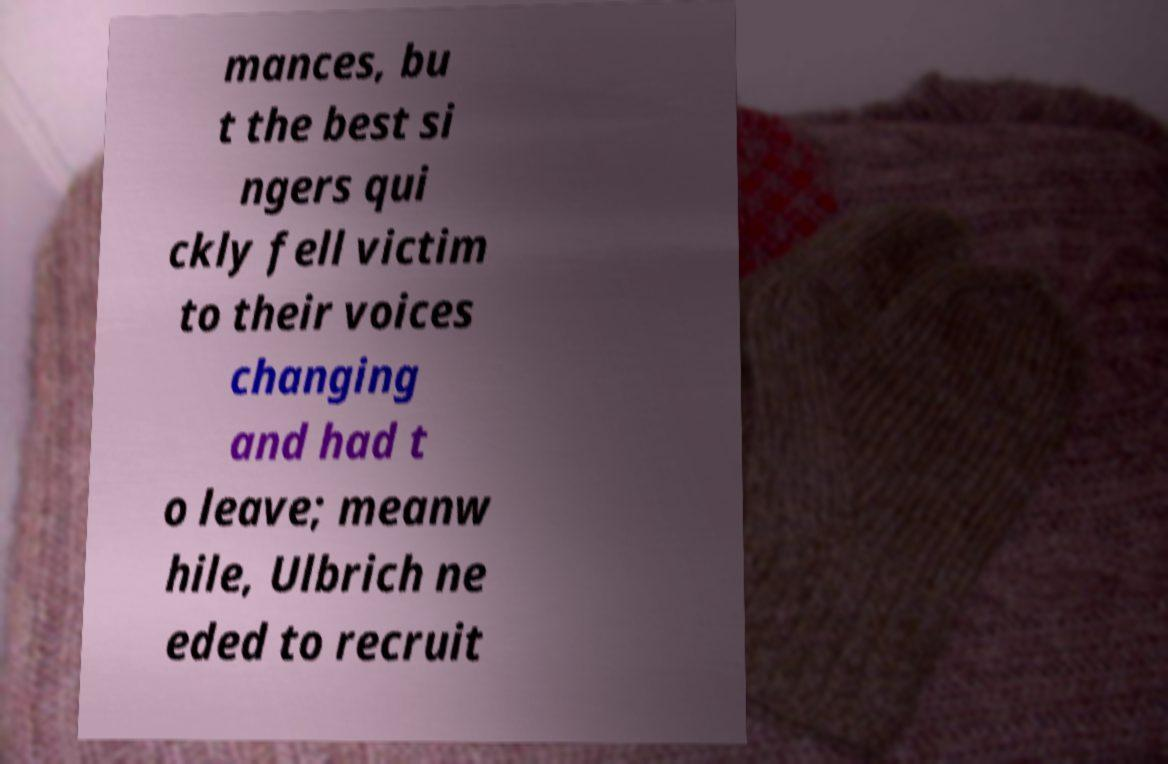There's text embedded in this image that I need extracted. Can you transcribe it verbatim? mances, bu t the best si ngers qui ckly fell victim to their voices changing and had t o leave; meanw hile, Ulbrich ne eded to recruit 